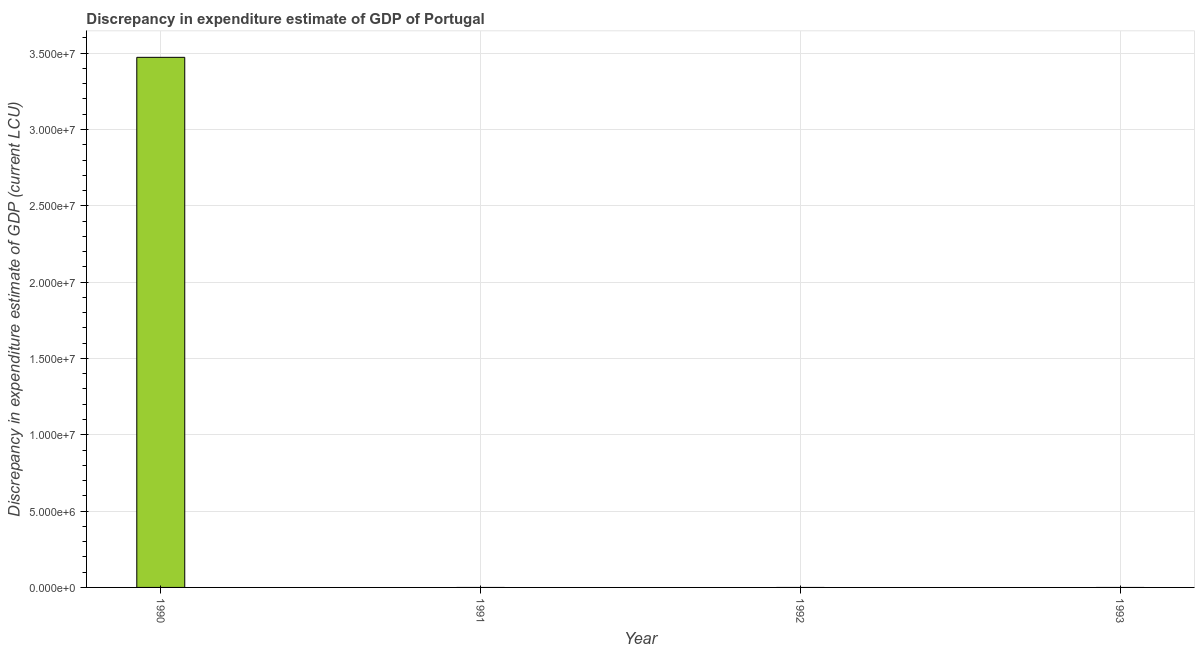Does the graph contain any zero values?
Offer a terse response. Yes. What is the title of the graph?
Give a very brief answer. Discrepancy in expenditure estimate of GDP of Portugal. What is the label or title of the X-axis?
Your response must be concise. Year. What is the label or title of the Y-axis?
Provide a succinct answer. Discrepancy in expenditure estimate of GDP (current LCU). What is the discrepancy in expenditure estimate of gdp in 1992?
Keep it short and to the point. 0. Across all years, what is the maximum discrepancy in expenditure estimate of gdp?
Offer a terse response. 3.47e+07. In which year was the discrepancy in expenditure estimate of gdp maximum?
Provide a short and direct response. 1990. What is the sum of the discrepancy in expenditure estimate of gdp?
Provide a succinct answer. 3.47e+07. What is the average discrepancy in expenditure estimate of gdp per year?
Your response must be concise. 8.68e+06. What is the median discrepancy in expenditure estimate of gdp?
Your response must be concise. 0. In how many years, is the discrepancy in expenditure estimate of gdp greater than 21000000 LCU?
Your answer should be very brief. 1. What is the difference between the highest and the lowest discrepancy in expenditure estimate of gdp?
Provide a succinct answer. 3.47e+07. Are all the bars in the graph horizontal?
Offer a terse response. No. Are the values on the major ticks of Y-axis written in scientific E-notation?
Ensure brevity in your answer.  Yes. What is the Discrepancy in expenditure estimate of GDP (current LCU) in 1990?
Ensure brevity in your answer.  3.47e+07. What is the Discrepancy in expenditure estimate of GDP (current LCU) in 1992?
Offer a terse response. 0. What is the Discrepancy in expenditure estimate of GDP (current LCU) in 1993?
Offer a very short reply. 0. 